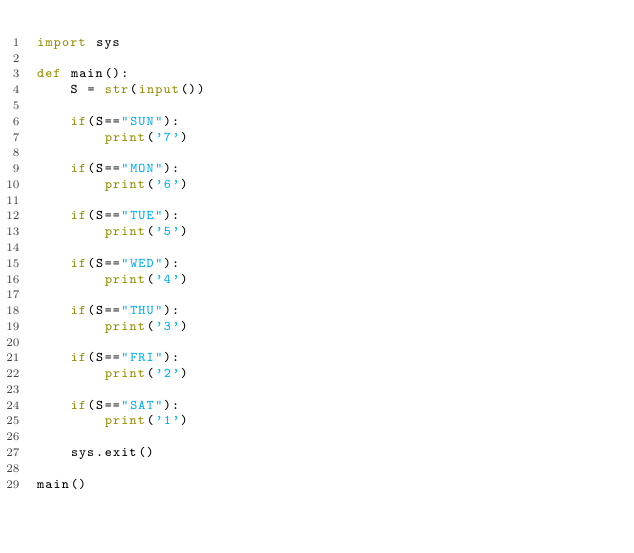<code> <loc_0><loc_0><loc_500><loc_500><_Python_>import sys

def main():
    S = str(input())

    if(S=="SUN"):
        print('7')

    if(S=="MON"):
        print('6')

    if(S=="TUE"):
        print('5')

    if(S=="WED"):
        print('4')

    if(S=="THU"):
        print('3')

    if(S=="FRI"):
        print('2')

    if(S=="SAT"):
        print('1')

    sys.exit()

main()</code> 